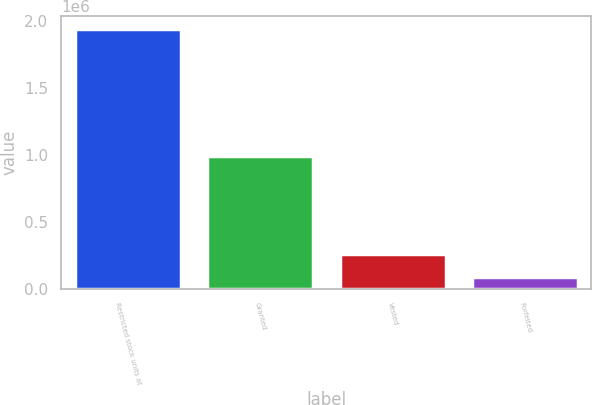<chart> <loc_0><loc_0><loc_500><loc_500><bar_chart><fcel>Restricted stock units at<fcel>Granted<fcel>Vested<fcel>Forfeited<nl><fcel>1.94032e+06<fcel>993652<fcel>260452<fcel>89553<nl></chart> 